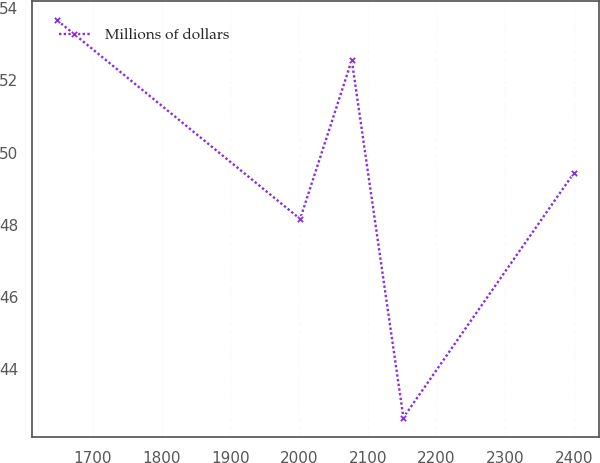Convert chart. <chart><loc_0><loc_0><loc_500><loc_500><line_chart><ecel><fcel>Millions of dollars<nl><fcel>1648.4<fcel>53.66<nl><fcel>2001.64<fcel>48.16<nl><fcel>2076.75<fcel>52.56<nl><fcel>2151.86<fcel>42.66<nl><fcel>2399.49<fcel>49.42<nl></chart> 